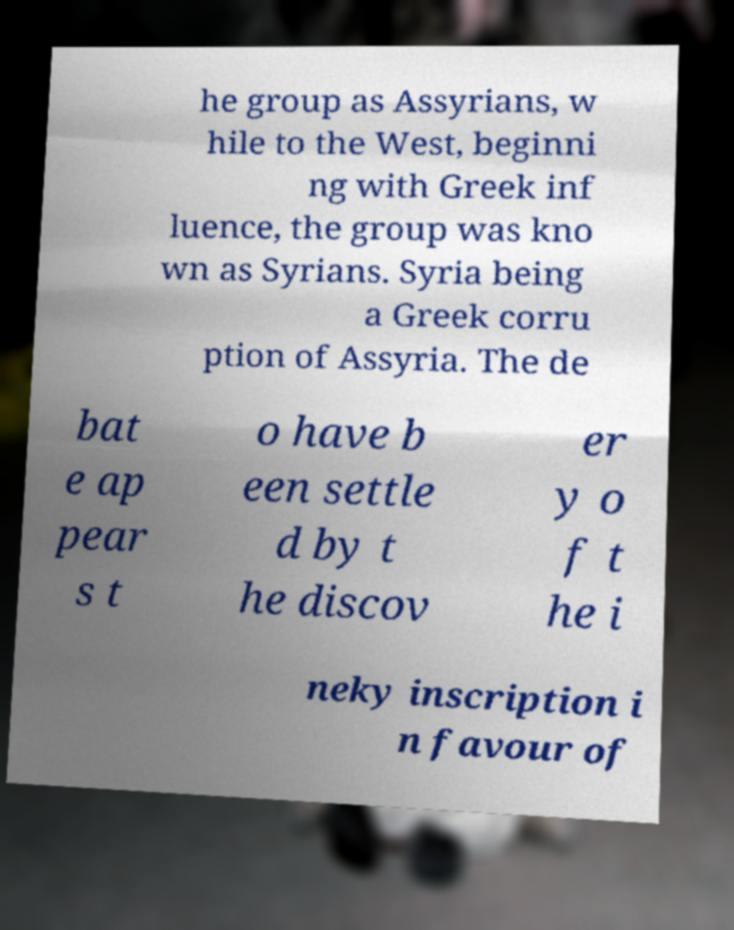Please read and relay the text visible in this image. What does it say? he group as Assyrians, w hile to the West, beginni ng with Greek inf luence, the group was kno wn as Syrians. Syria being a Greek corru ption of Assyria. The de bat e ap pear s t o have b een settle d by t he discov er y o f t he i neky inscription i n favour of 